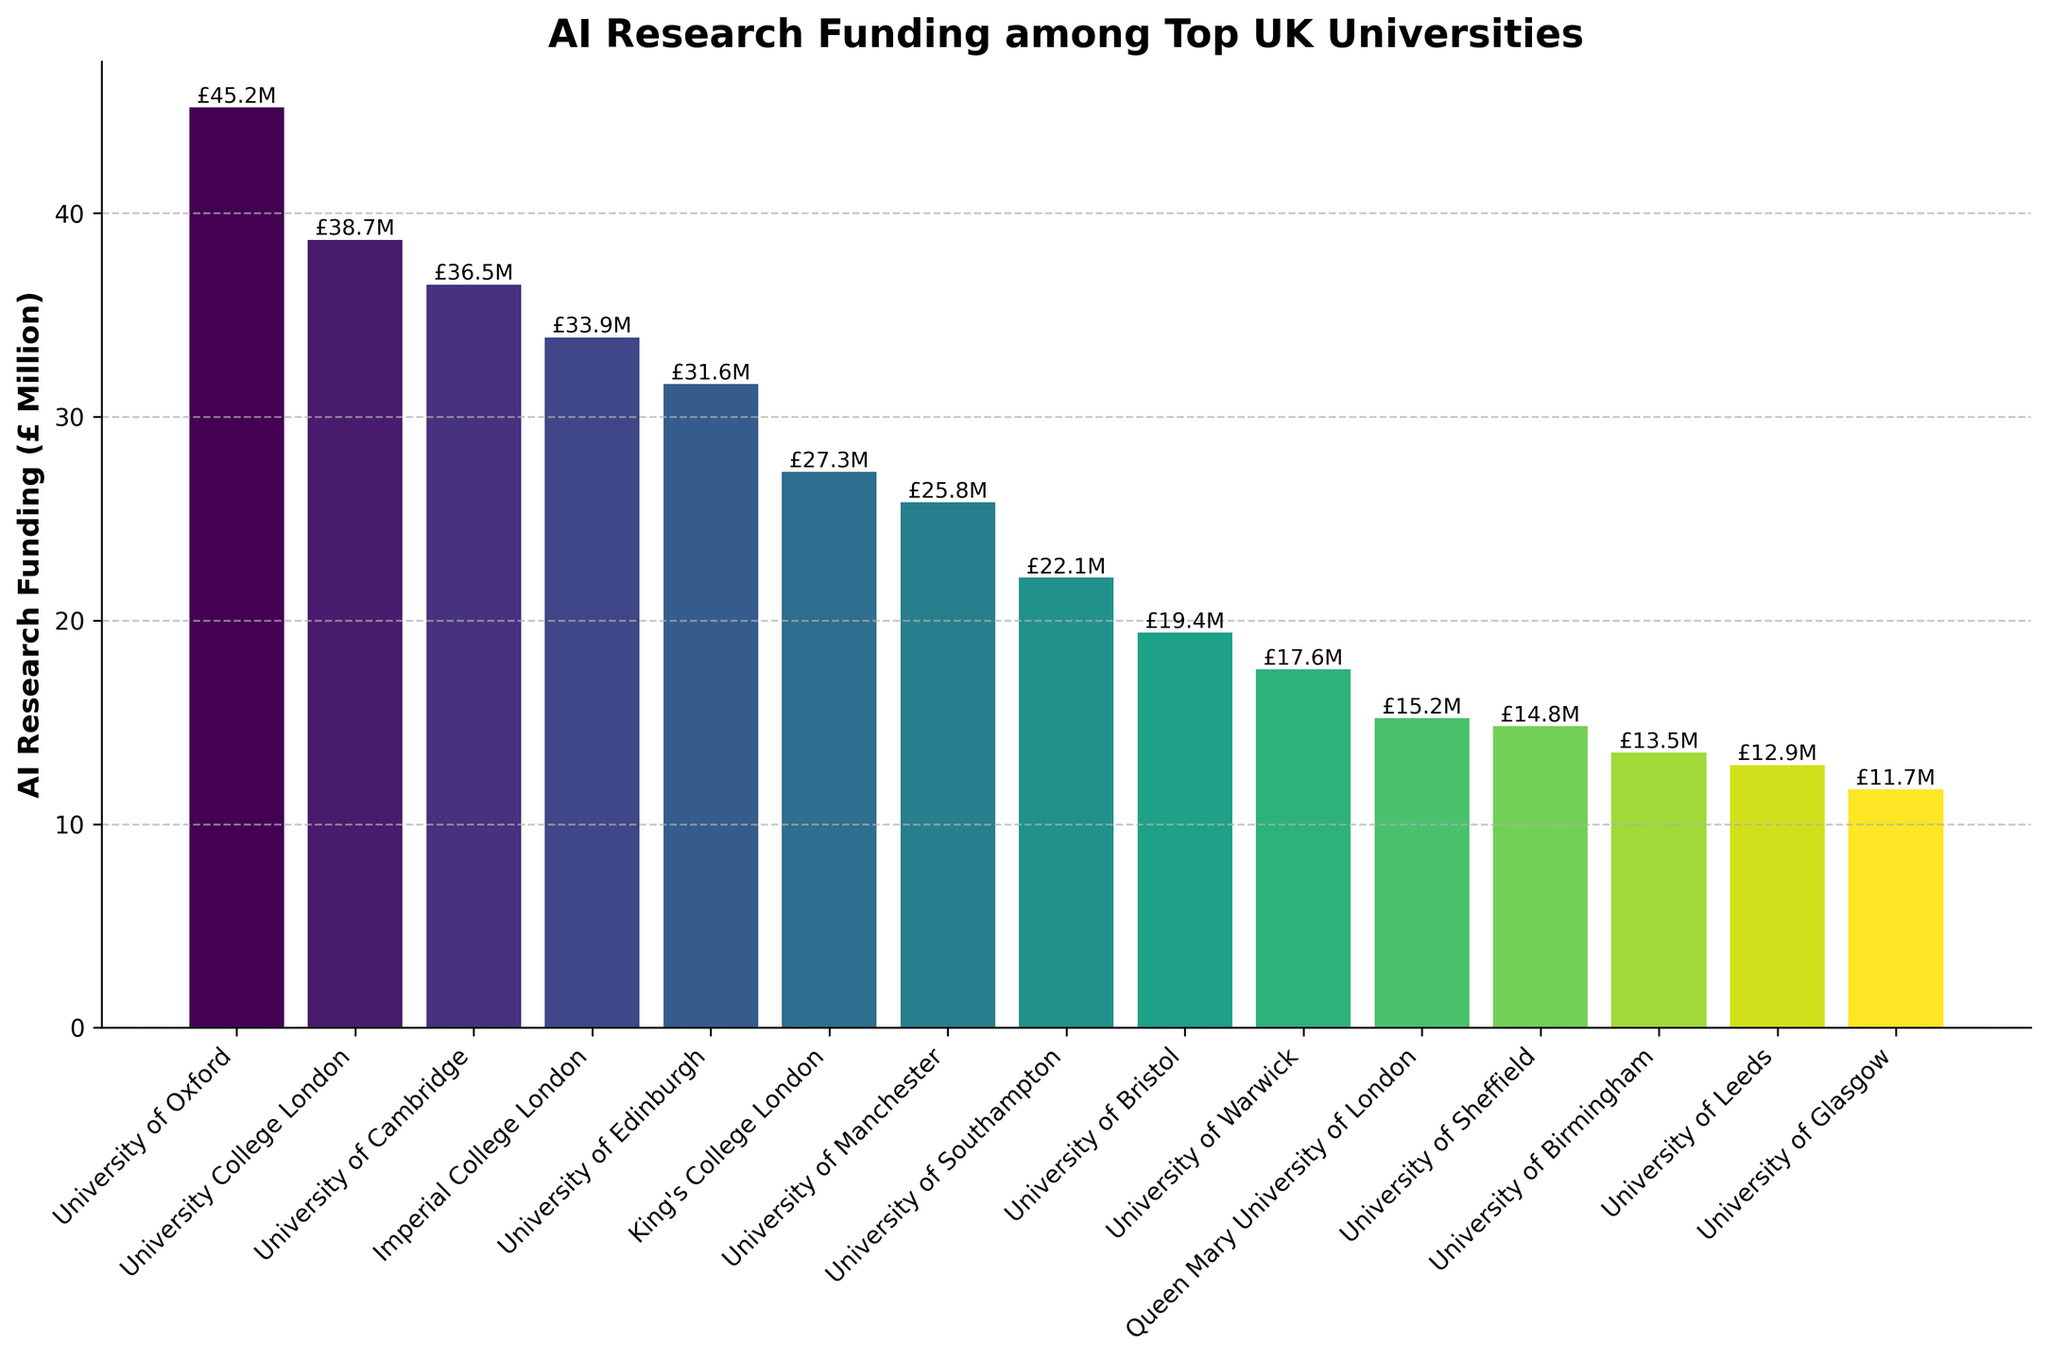What is the university with the highest AI research funding? The bar with the highest height represents the university with the highest AI research funding, which is the University of Oxford.
Answer: University of Oxford Which university has the lowest AI research funding and what is the amount? The bar with the lowest height represents the university with the lowest AI research funding, which is the University of Glasgow at £11.7 million.
Answer: University of Glasgow, £11.7 million What is the total AI research funding of the top 3 universities combined? The top 3 universities are University of Oxford (£45.2M), University College London (£38.7M), and University of Cambridge (£36.5M). Adding these amounts: 45.2 + 38.7 + 36.5 = 120.4
Answer: £120.4 million How much more AI research funding does University of Oxford have compared to University of Southampton? University of Oxford has £45.2M, and University of Southampton has £22.1M. The difference is 45.2 - 22.1 = 23.1
Answer: £23.1 million Which universities have AI research funding greater than £30 million but less than £40 million? The universities with AI funding between £30M and £40M are University College London (£38.7M), University of Cambridge (£36.5M), Imperial College London (£33.9M), and University of Edinburgh (£31.6M).
Answer: University College London, University of Cambridge, Imperial College London, University of Edinburgh What is the average AI research funding of the universities listed? Add all the funding amounts: 45.2 + 38.7 + 36.5 + 33.9 + 31.6 + 27.3 + 25.8 + 22.1 + 19.4 + 17.6 + 15.2 + 14.8 + 13.5 + 12.9 + 11.7 = 366.2. Divide by the number of universities (15): 366.2 / 15 = 24.41
Answer: £24.41 million Compare the AI research funding of King's College London to the University of Manchester. Which has higher funding and by how much? King's College London has £27.3M and University of Manchester has £25.8M. The difference is 27.3 - 25.8 = 1.5, so King's College London has £1.5 million more funding.
Answer: King's College London, £1.5 million Order the universities by AI research funding in descending order. Listing the universities from highest to lowest funding based on the height of the bars: University of Oxford, University College London, University of Cambridge, Imperial College London, University of Edinburgh, King's College London, University of Manchester, University of Southampton, University of Bristol, University of Warwick, Queen Mary University of London, University of Sheffield, University of Birmingham, University of Leeds, University of Glasgow.
Answer: University of Oxford, University College London, University of Cambridge, Imperial College London, University of Edinburgh, King's College London, University of Manchester, University of Southampton, University of Bristol, University of Warwick, Queen Mary University of London, University of Sheffield, University of Birmingham, University of Leeds, University of Glasgow What percentage of the total AI research funding does University of Edinburgh receive? The total AI research funding is 366.2. University of Edinburgh receives £31.6 million. The percentage is (31.6 / 366.2) * 100 ≈ 8.63%.
Answer: 8.63% What is the median AI research funding amount among the universities? Order the funding amounts and find the middle value. Ordered: 11.7, 12.9, 13.5, 14.8, 15.2, 17.6, 19.4, 22.1, 25.8, 27.3, 31.6, 33.9, 36.5, 38.7, 45.2. The middle value (8th in order) is 22.1.
Answer: £22.1 million 